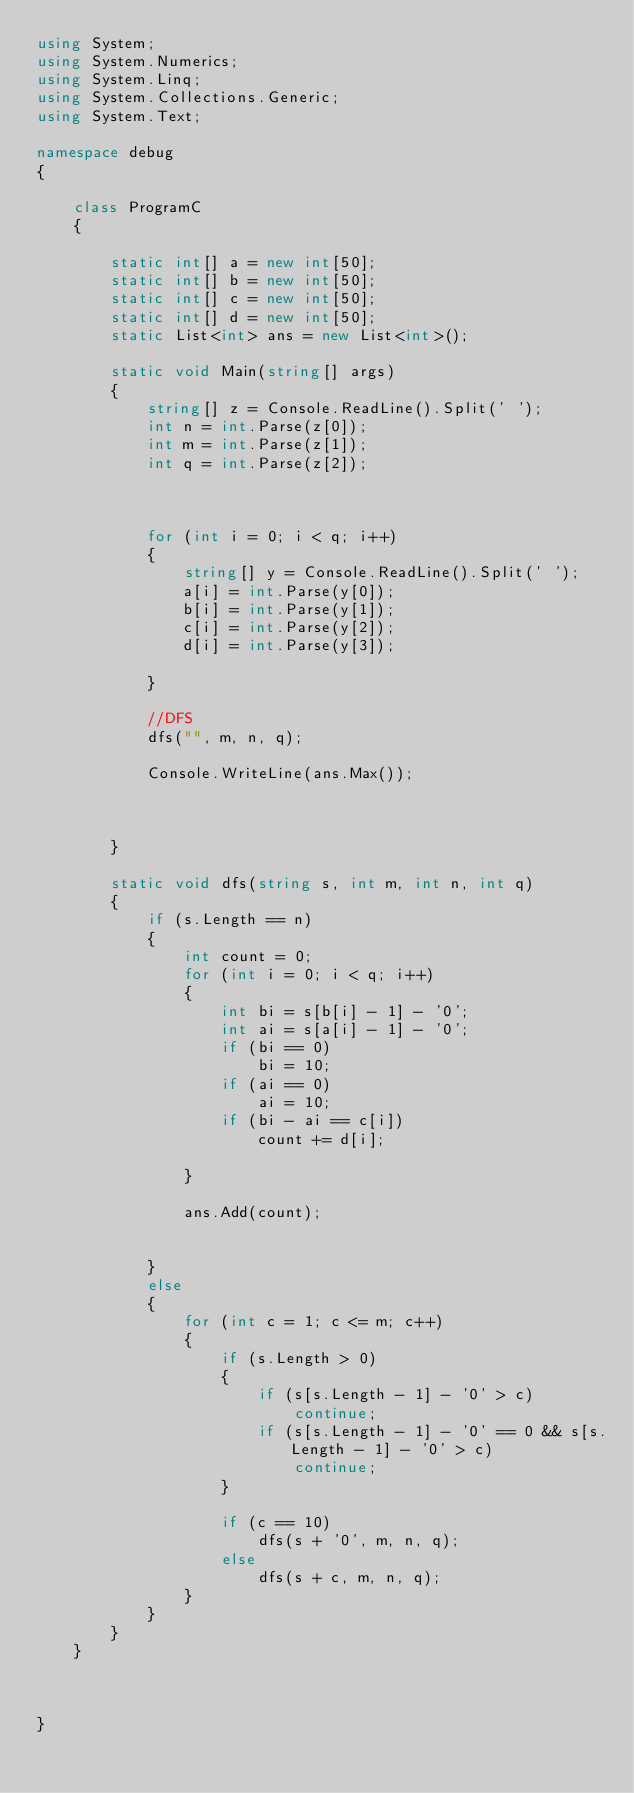Convert code to text. <code><loc_0><loc_0><loc_500><loc_500><_C#_>using System;
using System.Numerics;
using System.Linq;
using System.Collections.Generic;
using System.Text;

namespace debug
{

    class ProgramC
    {

        static int[] a = new int[50];
        static int[] b = new int[50];
        static int[] c = new int[50];
        static int[] d = new int[50];
        static List<int> ans = new List<int>();

        static void Main(string[] args)
        {
            string[] z = Console.ReadLine().Split(' ');
            int n = int.Parse(z[0]);
            int m = int.Parse(z[1]);
            int q = int.Parse(z[2]);



            for (int i = 0; i < q; i++)
            {
                string[] y = Console.ReadLine().Split(' ');
                a[i] = int.Parse(y[0]);
                b[i] = int.Parse(y[1]);
                c[i] = int.Parse(y[2]);
                d[i] = int.Parse(y[3]);

            }

            //DFS
            dfs("", m, n, q);

            Console.WriteLine(ans.Max());



        }

        static void dfs(string s, int m, int n, int q)
        {
            if (s.Length == n)
            {
                int count = 0;
                for (int i = 0; i < q; i++)
                {
                    int bi = s[b[i] - 1] - '0';
                    int ai = s[a[i] - 1] - '0';
                    if (bi == 0)
                        bi = 10;
                    if (ai == 0)
                        ai = 10;
                    if (bi - ai == c[i])
                        count += d[i];

                }

                ans.Add(count);


            }
            else
            {
                for (int c = 1; c <= m; c++)
                {
                    if (s.Length > 0)
                    {
                        if (s[s.Length - 1] - '0' > c)
                            continue;
                        if (s[s.Length - 1] - '0' == 0 && s[s.Length - 1] - '0' > c)
                            continue;
                    }

                    if (c == 10)
                        dfs(s + '0', m, n, q);
                    else
                        dfs(s + c, m, n, q);
                }
            }
        }
    }



}
</code> 